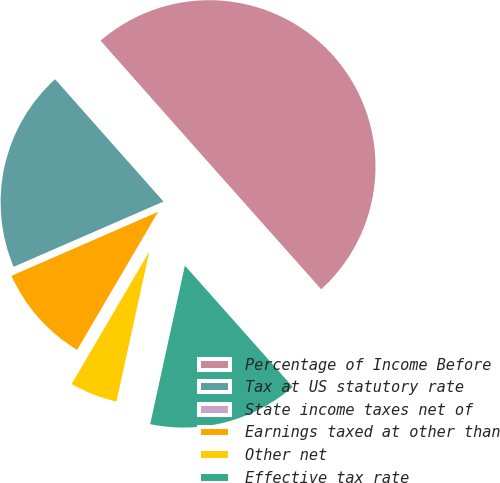<chart> <loc_0><loc_0><loc_500><loc_500><pie_chart><fcel>Percentage of Income Before<fcel>Tax at US statutory rate<fcel>State income taxes net of<fcel>Earnings taxed at other than<fcel>Other net<fcel>Effective tax rate<nl><fcel>49.97%<fcel>20.0%<fcel>0.01%<fcel>10.01%<fcel>5.01%<fcel>15.0%<nl></chart> 